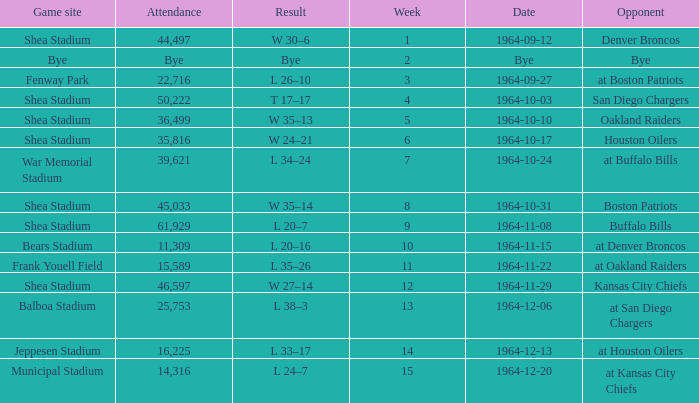In what venue did the jets have a game with an attendance of 11,309? Bears Stadium. 